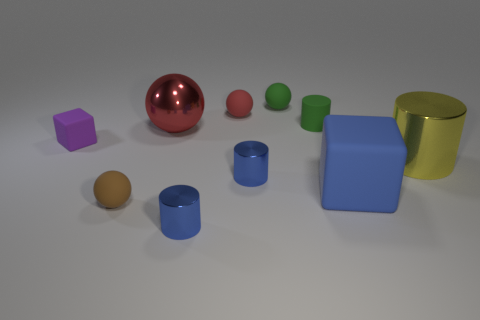Subtract all rubber cylinders. How many cylinders are left? 3 Subtract 1 blocks. How many blocks are left? 1 Subtract all purple cubes. How many cubes are left? 1 Subtract all spheres. How many objects are left? 6 Subtract all gray cylinders. Subtract all red balls. How many cylinders are left? 4 Subtract all cyan cylinders. How many gray spheres are left? 0 Subtract all small gray metallic balls. Subtract all tiny brown balls. How many objects are left? 9 Add 5 small purple cubes. How many small purple cubes are left? 6 Add 8 big green metal objects. How many big green metal objects exist? 8 Subtract 0 green blocks. How many objects are left? 10 